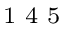Convert formula to latex. <formula><loc_0><loc_0><loc_500><loc_500>^ { 1 } 4 5</formula> 